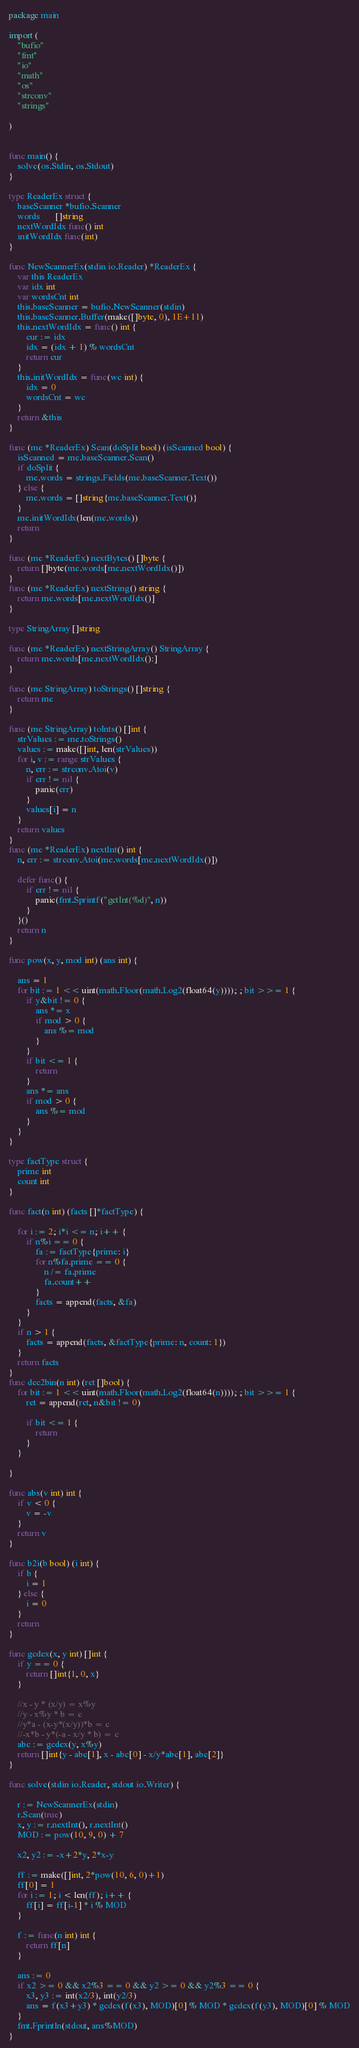<code> <loc_0><loc_0><loc_500><loc_500><_Go_>package main

import (
	"bufio"
	"fmt"
	"io"
	"math"
	"os"
	"strconv"
	"strings"

)


func main() {
	solve(os.Stdin, os.Stdout)
}

type ReaderEx struct {
	baseScanner *bufio.Scanner
	words       []string
	nextWordIdx func() int
	initWordIdx func(int)
}

func NewScannerEx(stdin io.Reader) *ReaderEx {
	var this ReaderEx
	var idx int
	var wordsCnt int
	this.baseScanner = bufio.NewScanner(stdin)
	this.baseScanner.Buffer(make([]byte, 0), 1E+11)
	this.nextWordIdx = func() int {
		cur := idx
		idx = (idx + 1) % wordsCnt
		return cur
	}
	this.initWordIdx = func(wc int) {
		idx = 0
		wordsCnt = wc
	}
	return &this
}

func (me *ReaderEx) Scan(doSplit bool) (isScanned bool) {
	isScanned = me.baseScanner.Scan()
	if doSplit {
		me.words = strings.Fields(me.baseScanner.Text())
	} else {
		me.words = []string{me.baseScanner.Text()}
	}
	me.initWordIdx(len(me.words))
	return
}

func (me *ReaderEx) nextBytes() []byte {
	return []byte(me.words[me.nextWordIdx()])
}
func (me *ReaderEx) nextString() string {
	return me.words[me.nextWordIdx()]
}

type StringArray []string

func (me *ReaderEx) nextStringArray() StringArray {
	return me.words[me.nextWordIdx():]
}

func (me StringArray) toStrings() []string {
	return me
}

func (me StringArray) toInts() []int {
	strValues := me.toStrings()
	values := make([]int, len(strValues))
	for i, v := range strValues {
		n, err := strconv.Atoi(v)
		if err != nil {
			panic(err)
		}
		values[i] = n
	}
	return values
}
func (me *ReaderEx) nextInt() int {
	n, err := strconv.Atoi(me.words[me.nextWordIdx()])

	defer func() {
		if err != nil {
			panic(fmt.Sprintf("getInt(%d)", n))
		}
	}()
	return n
}

func pow(x, y, mod int) (ans int) {

	ans = 1
	for bit := 1 << uint(math.Floor(math.Log2(float64(y)))); ; bit >>= 1 {
		if y&bit != 0 {
			ans *= x
			if mod > 0 {
				ans %= mod
			}
		}
		if bit <= 1 {
			return
		}
		ans *= ans
		if mod > 0 {
			ans %= mod
		}
	}
}

type factType struct {
	prime int
	count int
}

func fact(n int) (facts []*factType) {

	for i := 2; i*i <= n; i++ {
		if n%i == 0 {
			fa := factType{prime: i}
			for n%fa.prime == 0 {
				n /= fa.prime
				fa.count++
			}
			facts = append(facts, &fa)
		}
	}
	if n > 1 {
		facts = append(facts, &factType{prime: n, count: 1})
	}
	return facts
}
func dec2bin(n int) (ret []bool) {
	for bit := 1 << uint(math.Floor(math.Log2(float64(n)))); ; bit >>= 1 {
		ret = append(ret, n&bit != 0)

		if bit <= 1 {
			return
		}
	}

}

func abs(v int) int {
	if v < 0 {
		v = -v
	}
	return v
}

func b2i(b bool) (i int) {
	if b {
		i = 1
	} else {
		i = 0
	}
	return
}

func gcdex(x, y int) []int {
	if y == 0 {
		return []int{1, 0, x}
	}

	//x - y * (x/y) = x%y
	//y - x%y * b = c
	//y*a - (x-y*(x/y))*b = c
	//-x*b - y*(-a - x/y * b) = c
	abc := gcdex(y, x%y)
	return []int{y - abc[1], x - abc[0] - x/y*abc[1], abc[2]}
}

func solve(stdin io.Reader, stdout io.Writer) {

	r := NewScannerEx(stdin)
	r.Scan(true)
	x, y := r.nextInt(), r.nextInt()
	MOD := pow(10, 9, 0) + 7

	x2, y2 := -x+2*y, 2*x-y

	ff := make([]int, 2*pow(10, 6, 0)+1)
	ff[0] = 1
	for i := 1; i < len(ff); i++ {
		ff[i] = ff[i-1] * i % MOD
	}

	f := func(n int) int {
		return ff[n]
	}

	ans := 0
	if x2 >= 0 && x2%3 == 0 && y2 >= 0 && y2%3 == 0 {
		x3, y3 := int(x2/3), int(y2/3)
		ans = f(x3+y3) * gcdex(f(x3), MOD)[0] % MOD * gcdex(f(y3), MOD)[0] % MOD
	}
	fmt.Fprintln(stdout, ans%MOD)
}
</code> 